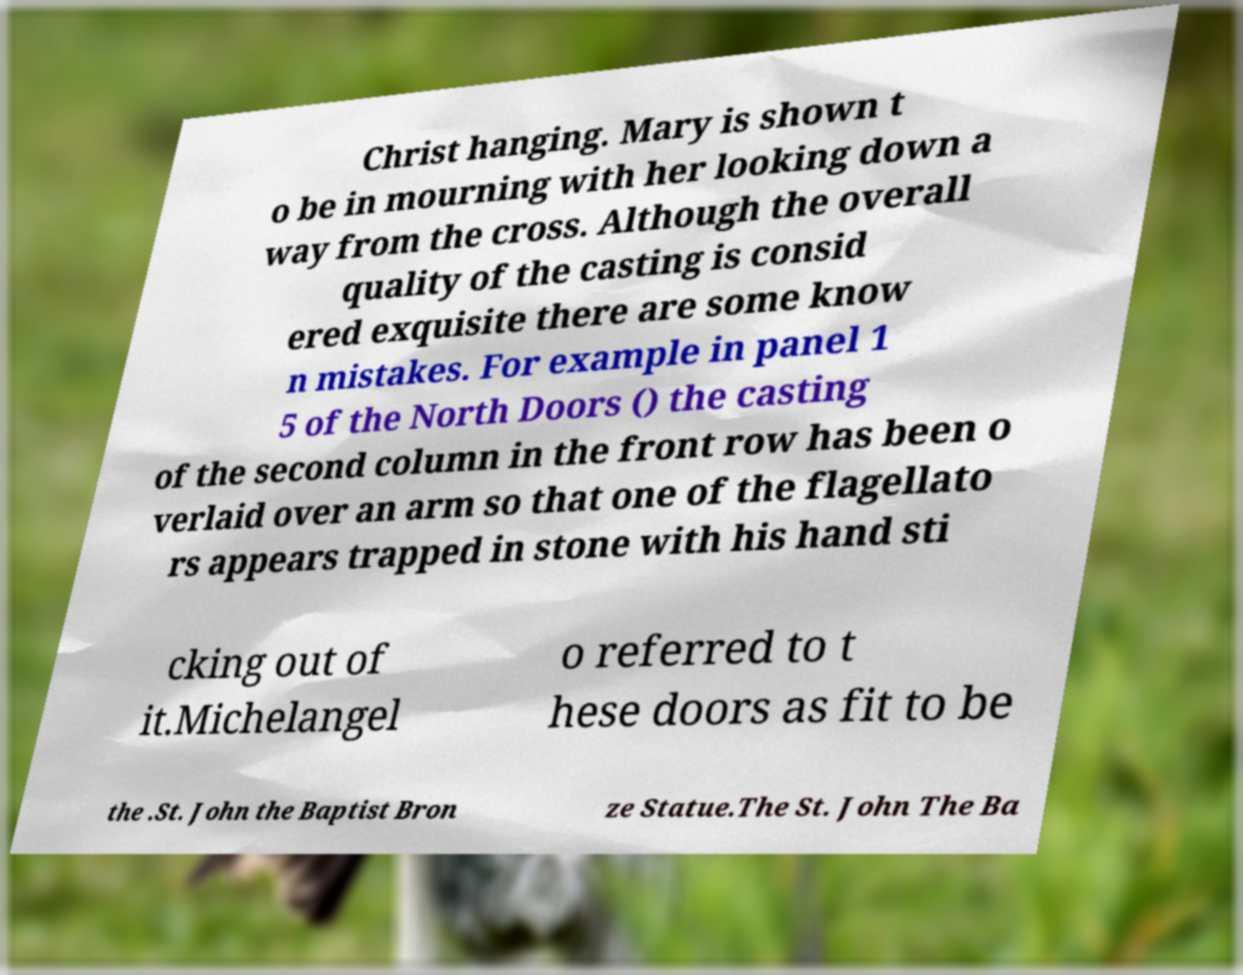For documentation purposes, I need the text within this image transcribed. Could you provide that? Christ hanging. Mary is shown t o be in mourning with her looking down a way from the cross. Although the overall quality of the casting is consid ered exquisite there are some know n mistakes. For example in panel 1 5 of the North Doors () the casting of the second column in the front row has been o verlaid over an arm so that one of the flagellato rs appears trapped in stone with his hand sti cking out of it.Michelangel o referred to t hese doors as fit to be the .St. John the Baptist Bron ze Statue.The St. John The Ba 